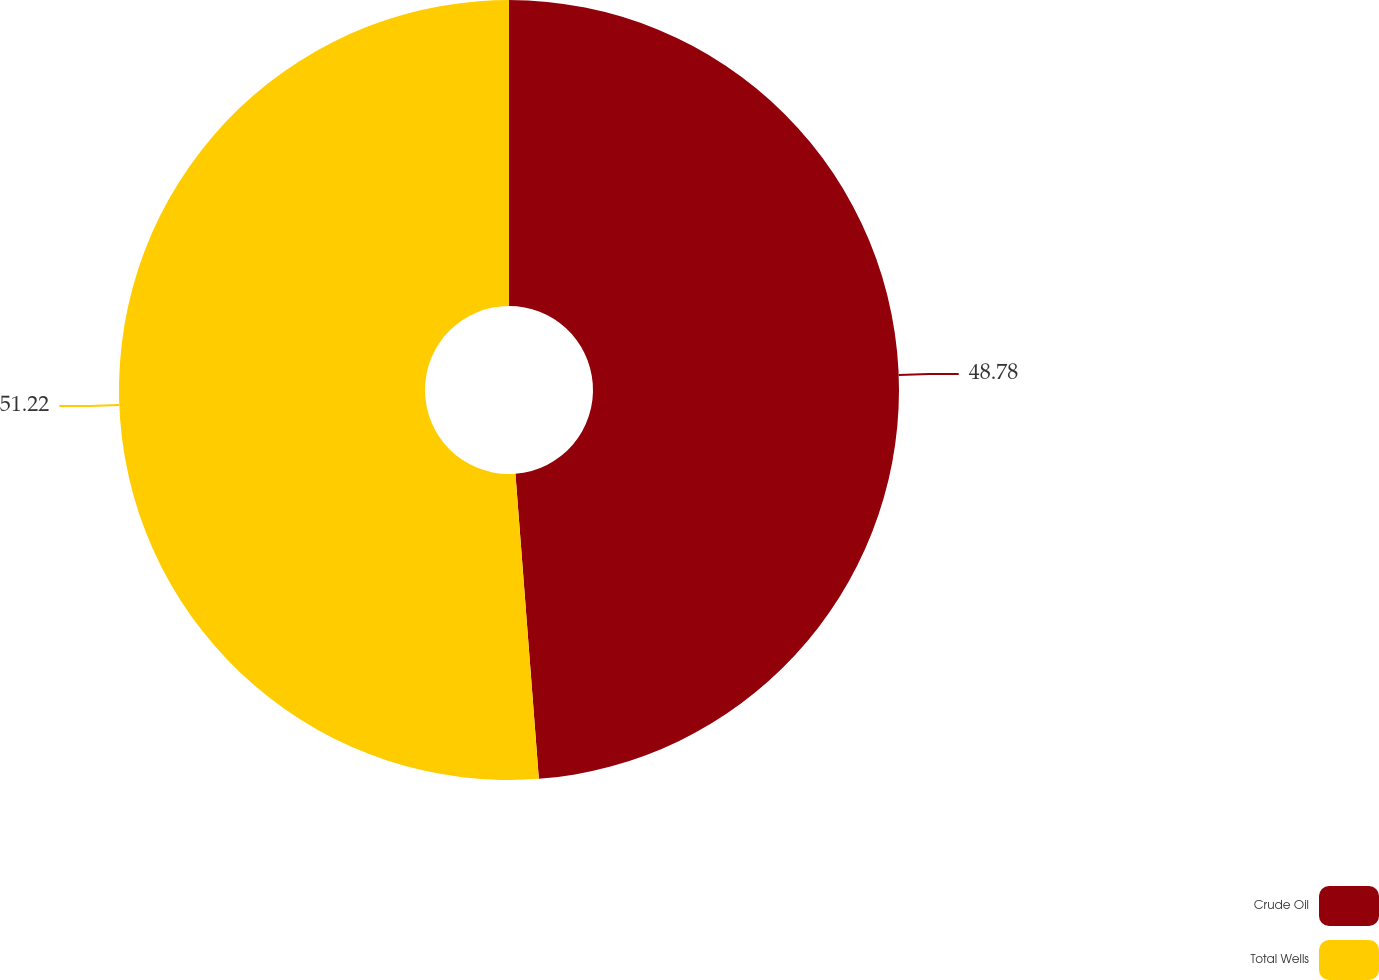Convert chart to OTSL. <chart><loc_0><loc_0><loc_500><loc_500><pie_chart><fcel>Crude Oil<fcel>Total Wells<nl><fcel>48.78%<fcel>51.22%<nl></chart> 